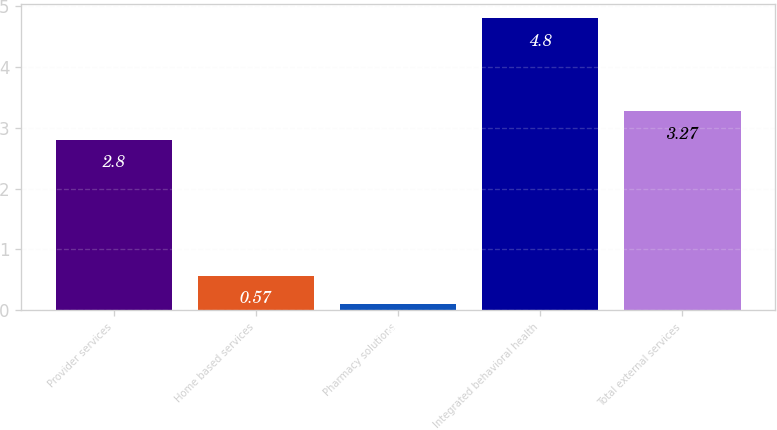Convert chart. <chart><loc_0><loc_0><loc_500><loc_500><bar_chart><fcel>Provider services<fcel>Home based services<fcel>Pharmacy solutions<fcel>Integrated behavioral health<fcel>Total external services<nl><fcel>2.8<fcel>0.57<fcel>0.1<fcel>4.8<fcel>3.27<nl></chart> 